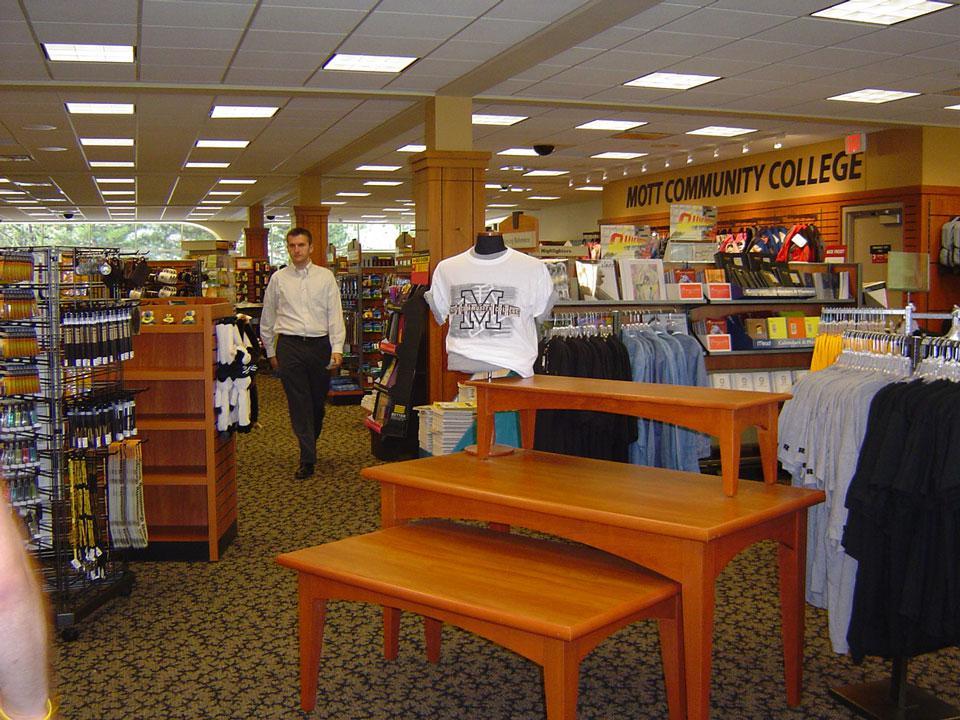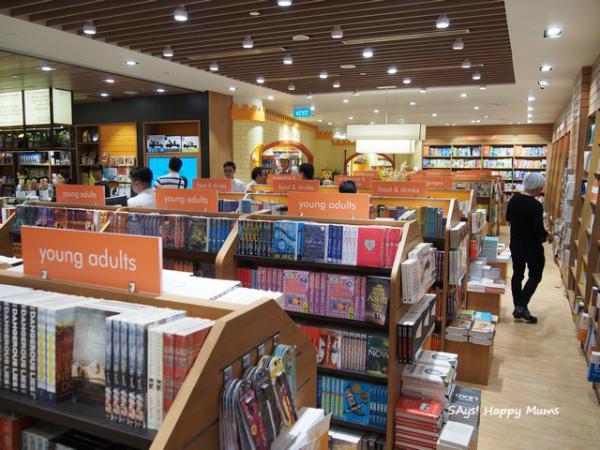The first image is the image on the left, the second image is the image on the right. Examine the images to the left and right. Is the description "An image shows a shop interior which includes displays of apparel." accurate? Answer yes or no. Yes. 